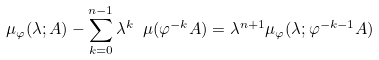<formula> <loc_0><loc_0><loc_500><loc_500>\mu _ { \varphi } ( \lambda ; A ) - \sum _ { k = 0 } ^ { n - 1 } \lambda ^ { k } \ \mu ( \varphi ^ { - k } A ) = \lambda ^ { n + 1 } \mu _ { \varphi } ( \lambda ; \varphi ^ { - k - 1 } A )</formula> 